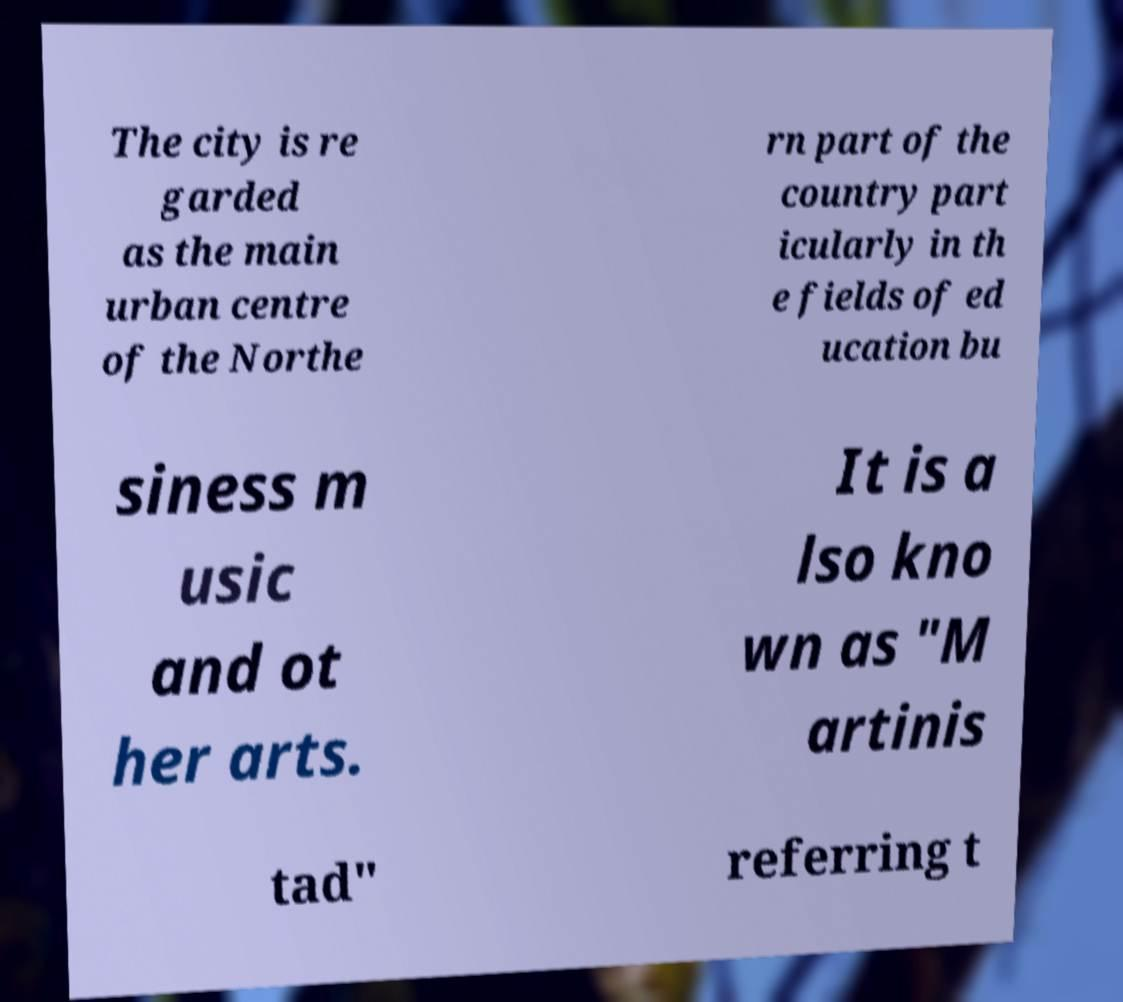Can you read and provide the text displayed in the image?This photo seems to have some interesting text. Can you extract and type it out for me? The city is re garded as the main urban centre of the Northe rn part of the country part icularly in th e fields of ed ucation bu siness m usic and ot her arts. It is a lso kno wn as "M artinis tad" referring t 